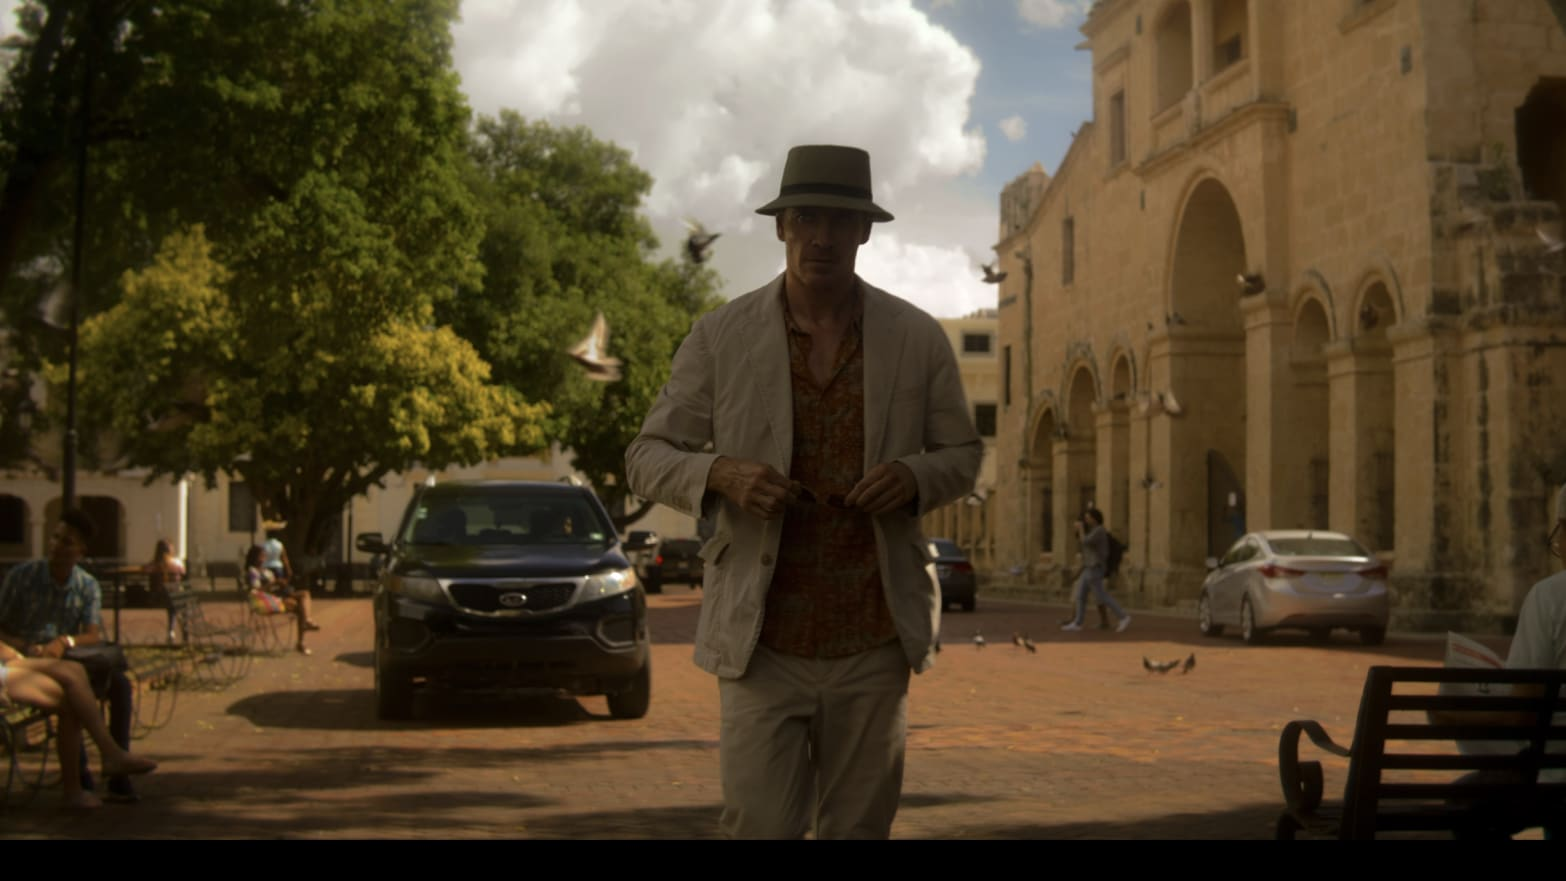Can you describe the architecture visible in the background? The architecture in the background features elements typical of colonial style, visible in the church’s arched doorways and stone facade. The building suggests historical significance and is likely a prominent landmark in this area. 